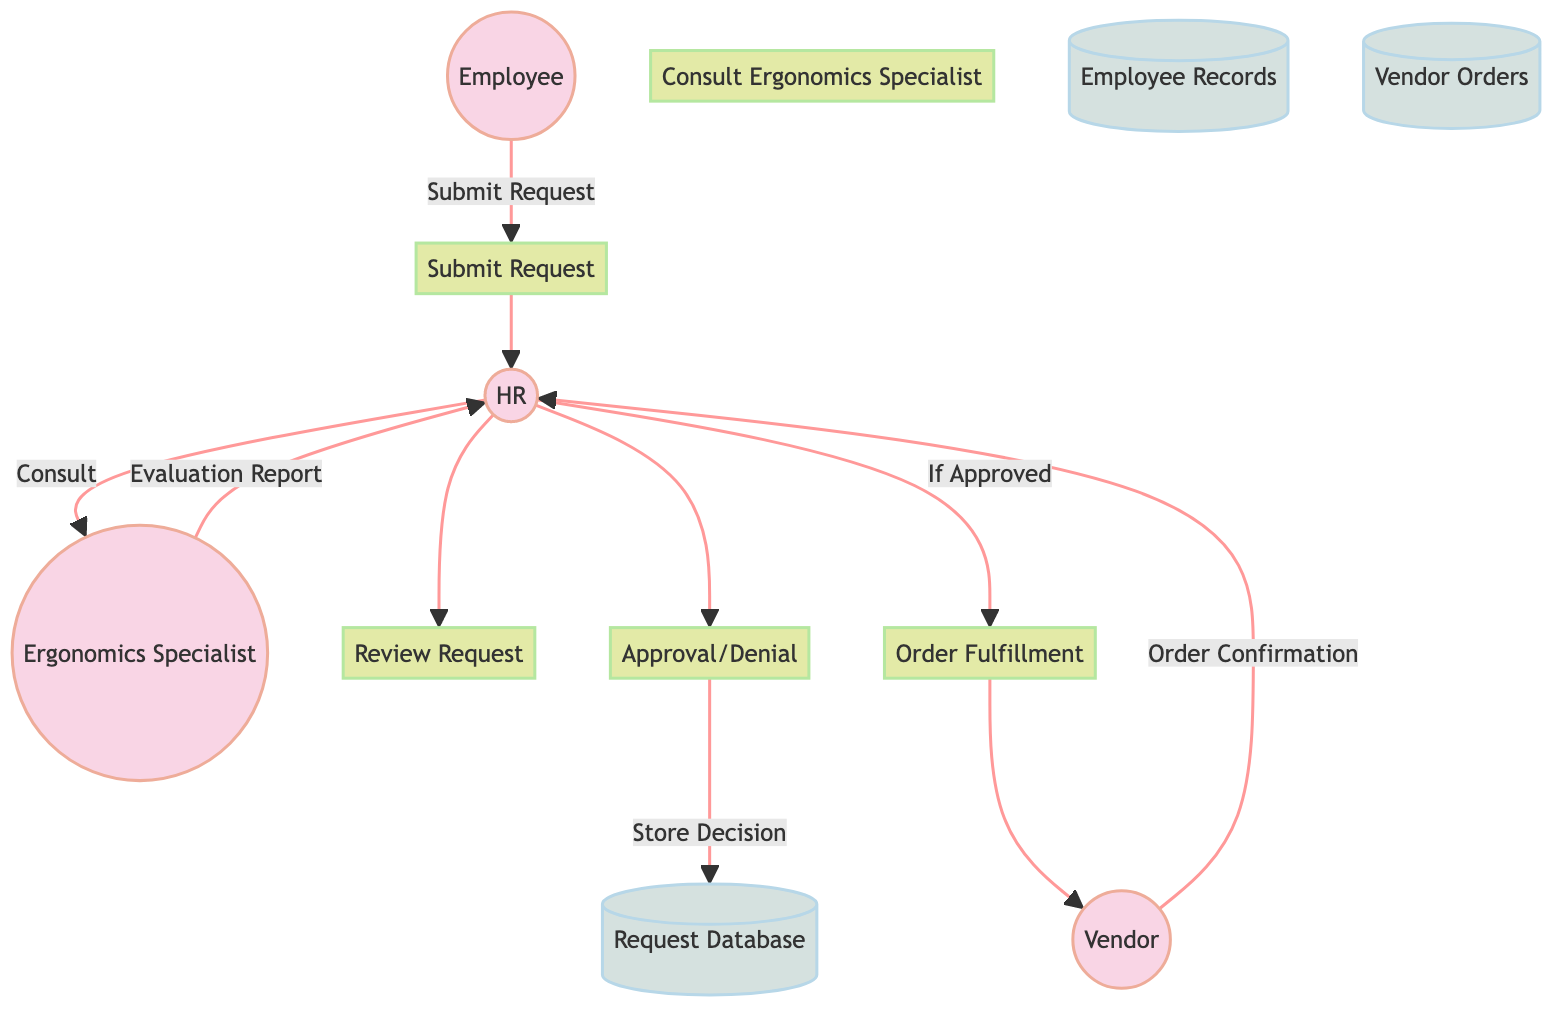What is the first process in the diagram? The first process is labeled as "Submit Request," which follows the employee node in the flowchart.
Answer: Submit Request How many entities are present in the diagram? The diagram features four entities: Employee, Human Resources, Ergonomics Specialist, and Vendor.
Answer: Four What does the Ergonomics Specialist provide to HR? The Ergonomics Specialist delivers an "Evaluation Report" to HR after consulting on a request.
Answer: Evaluation Report Which entity is responsible for approving or denying requests? Human Resources is responsible for making the decision to approve or deny ergonomic equipment requests based on the evaluation.
Answer: Human Resources What happens to the request if it is approved? If the request is approved, HR forwards it to the Vendor for fulfillment, which is indicated by the "Order Fulfillment" process leading to the Vendor entity.
Answer: Vendor What data store contains the details of orders placed with Vendors? The data store for vendor orders is labeled "Vendor Orders" in the diagram, which keeps track of all the details of orders.
Answer: Vendor Orders Which process follows the "Review Request" step? The process that follows "Review Request" is "Consult Ergonomics Specialist," indicating a need for further expertise on the request.
Answer: Consult Ergonomics Specialist What is the relationship between HR and the Request Database? HR stores the approved or denied decision in the Request Database, which shows a direct data flow from HR to Request Database during the approval process.
Answer: Store Approved/Denied Decision How does the Vendor confirm the order? The Vendor sends back an "Order Confirmation" to HR after fulfilling the order, completing the data flow from the Vendor back to HR.
Answer: Order Confirmation 